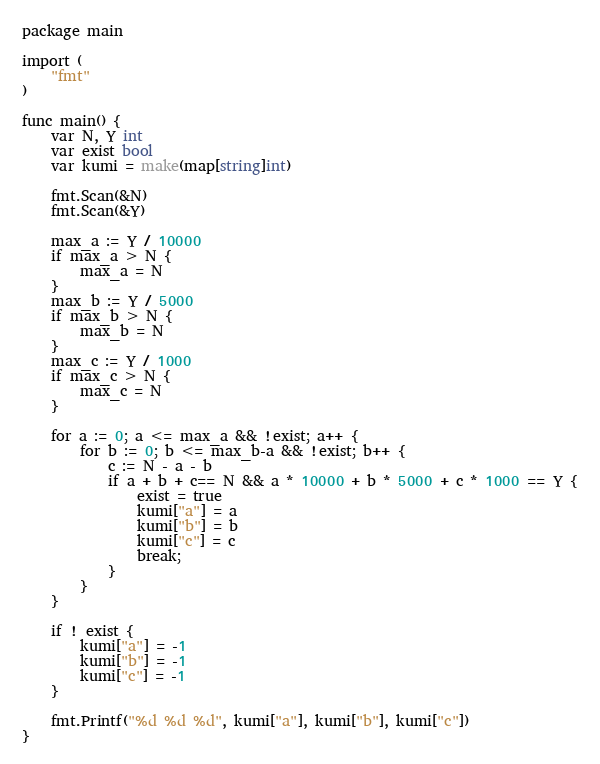Convert code to text. <code><loc_0><loc_0><loc_500><loc_500><_Go_>package main

import (
	"fmt"
)

func main() {
	var N, Y int
	var exist bool
	var kumi = make(map[string]int)

	fmt.Scan(&N)
	fmt.Scan(&Y)

	max_a := Y / 10000
	if max_a > N {
		max_a = N
	}
	max_b := Y / 5000
	if max_b > N {
		max_b = N
	}
	max_c := Y / 1000
	if max_c > N {
		max_c = N
	}
	
	for a := 0; a <= max_a && !exist; a++ {
		for b := 0; b <= max_b-a && !exist; b++ {
			c := N - a - b
			if a + b + c== N && a * 10000 + b * 5000 + c * 1000 == Y {
				exist = true
				kumi["a"] = a
				kumi["b"] = b
				kumi["c"] = c
				break;
			}
		}
	}

	if ! exist {
		kumi["a"] = -1
		kumi["b"] = -1
		kumi["c"] = -1
	}

	fmt.Printf("%d %d %d", kumi["a"], kumi["b"], kumi["c"])
}</code> 